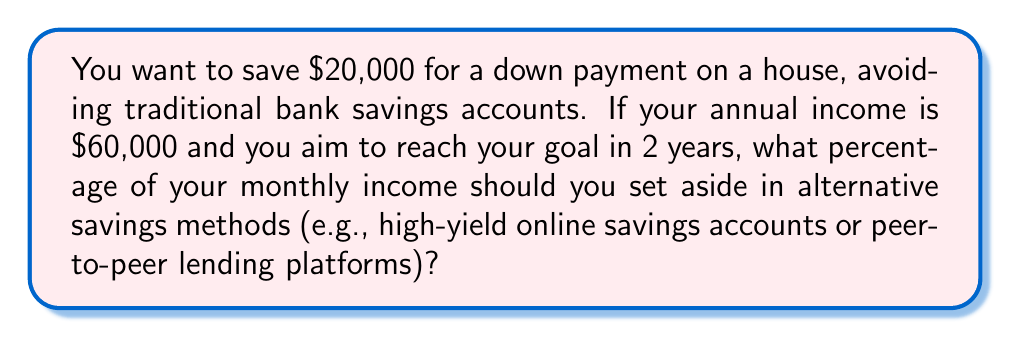Solve this math problem. Let's break this down step-by-step:

1. Calculate the monthly income:
   Annual income = $60,000
   Monthly income = $60,000 ÷ 12 = $5,000

2. Determine the monthly savings needed:
   Total savings goal = $20,000
   Time frame = 2 years = 24 months
   Monthly savings = $20,000 ÷ 24 = $833.33

3. Calculate the percentage of monthly income needed for savings:
   $$\text{Percentage} = \frac{\text{Monthly savings}}{\text{Monthly income}} \times 100\%$$
   $$\text{Percentage} = \frac{833.33}{5000} \times 100\% = 0.16666 \times 100\% = 16.67\%$$

Therefore, you need to save 16.67% of your monthly income to reach your goal.
Answer: 16.67% 